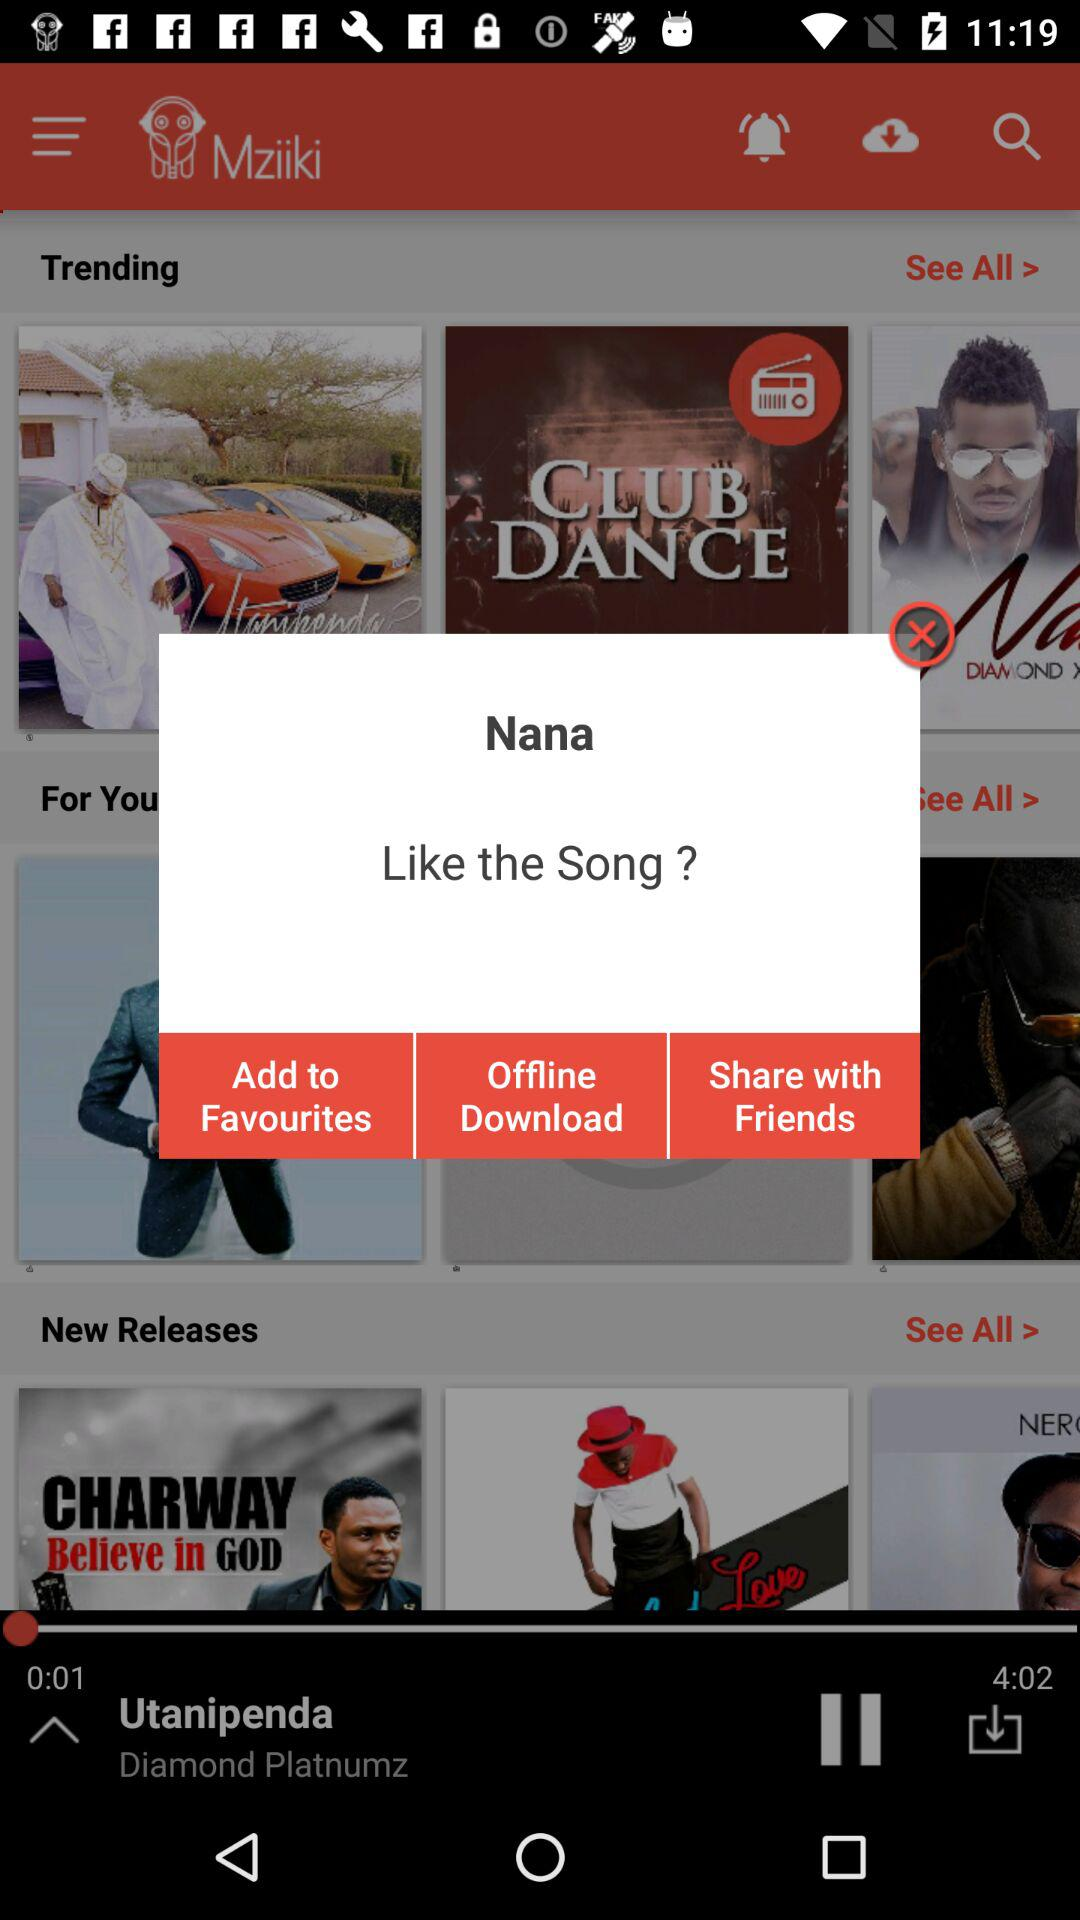Who is the singer? The singer is "Diamond Platinumz". 